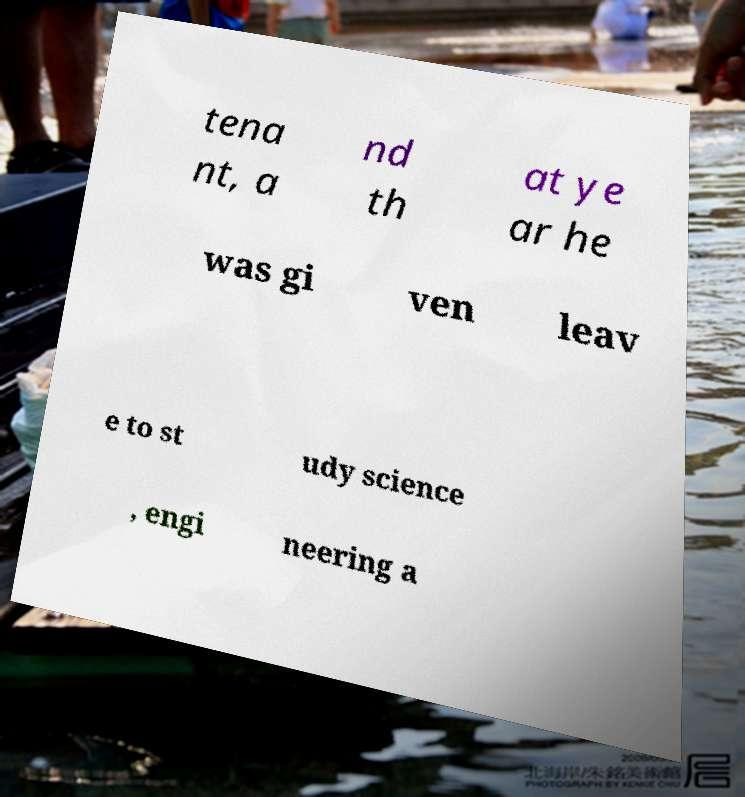What messages or text are displayed in this image? I need them in a readable, typed format. tena nt, a nd th at ye ar he was gi ven leav e to st udy science , engi neering a 